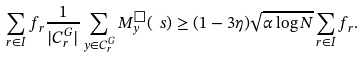<formula> <loc_0><loc_0><loc_500><loc_500>\sum _ { r \in I } f _ { r } \frac { 1 } { | C ^ { G } _ { r } | } \sum _ { y \in C ^ { G } _ { r } } M _ { y } ^ { \Box } ( \ s ) \geq ( 1 - 3 \eta ) \sqrt { \alpha \log N } \sum _ { r \in I } f _ { r } .</formula> 